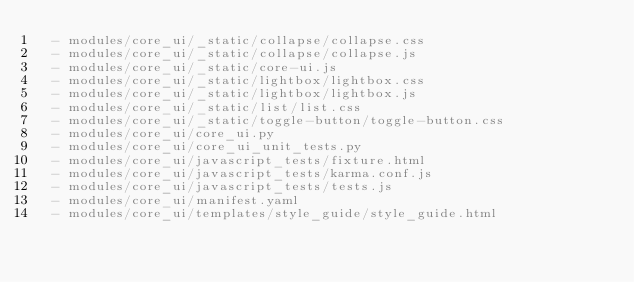Convert code to text. <code><loc_0><loc_0><loc_500><loc_500><_YAML_>  - modules/core_ui/_static/collapse/collapse.css
  - modules/core_ui/_static/collapse/collapse.js
  - modules/core_ui/_static/core-ui.js
  - modules/core_ui/_static/lightbox/lightbox.css
  - modules/core_ui/_static/lightbox/lightbox.js
  - modules/core_ui/_static/list/list.css
  - modules/core_ui/_static/toggle-button/toggle-button.css
  - modules/core_ui/core_ui.py
  - modules/core_ui/core_ui_unit_tests.py
  - modules/core_ui/javascript_tests/fixture.html
  - modules/core_ui/javascript_tests/karma.conf.js
  - modules/core_ui/javascript_tests/tests.js
  - modules/core_ui/manifest.yaml
  - modules/core_ui/templates/style_guide/style_guide.html
</code> 